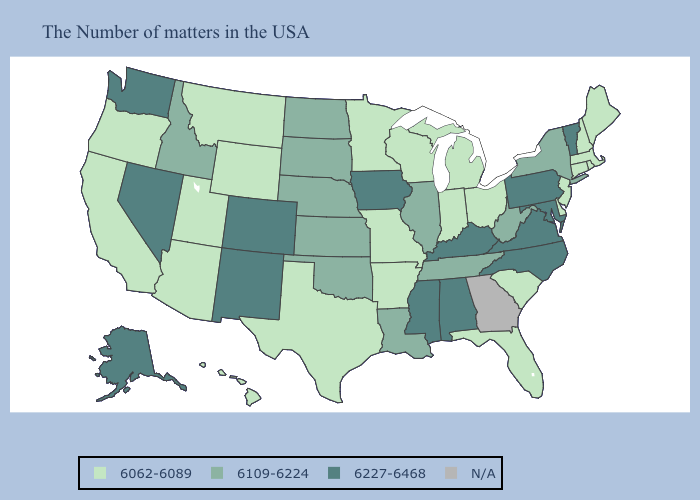Name the states that have a value in the range N/A?
Be succinct. Georgia. Among the states that border Georgia , which have the lowest value?
Keep it brief. South Carolina, Florida. Among the states that border Utah , does Nevada have the highest value?
Short answer required. Yes. Which states hav the highest value in the West?
Concise answer only. Colorado, New Mexico, Nevada, Washington, Alaska. What is the lowest value in the USA?
Quick response, please. 6062-6089. Among the states that border West Virginia , which have the highest value?
Short answer required. Maryland, Pennsylvania, Virginia, Kentucky. Does Alaska have the highest value in the USA?
Short answer required. Yes. What is the value of Vermont?
Answer briefly. 6227-6468. Which states hav the highest value in the West?
Short answer required. Colorado, New Mexico, Nevada, Washington, Alaska. What is the value of Alaska?
Concise answer only. 6227-6468. Name the states that have a value in the range 6109-6224?
Keep it brief. New York, West Virginia, Tennessee, Illinois, Louisiana, Kansas, Nebraska, Oklahoma, South Dakota, North Dakota, Idaho. What is the value of Nevada?
Keep it brief. 6227-6468. 